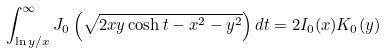<formula> <loc_0><loc_0><loc_500><loc_500>\int _ { \ln y / x } ^ { \infty } J _ { 0 } \left ( \sqrt { 2 x y \cosh t - x ^ { 2 } - y ^ { 2 } } \right ) d t = 2 I _ { 0 } ( x ) K _ { 0 } ( y )</formula> 